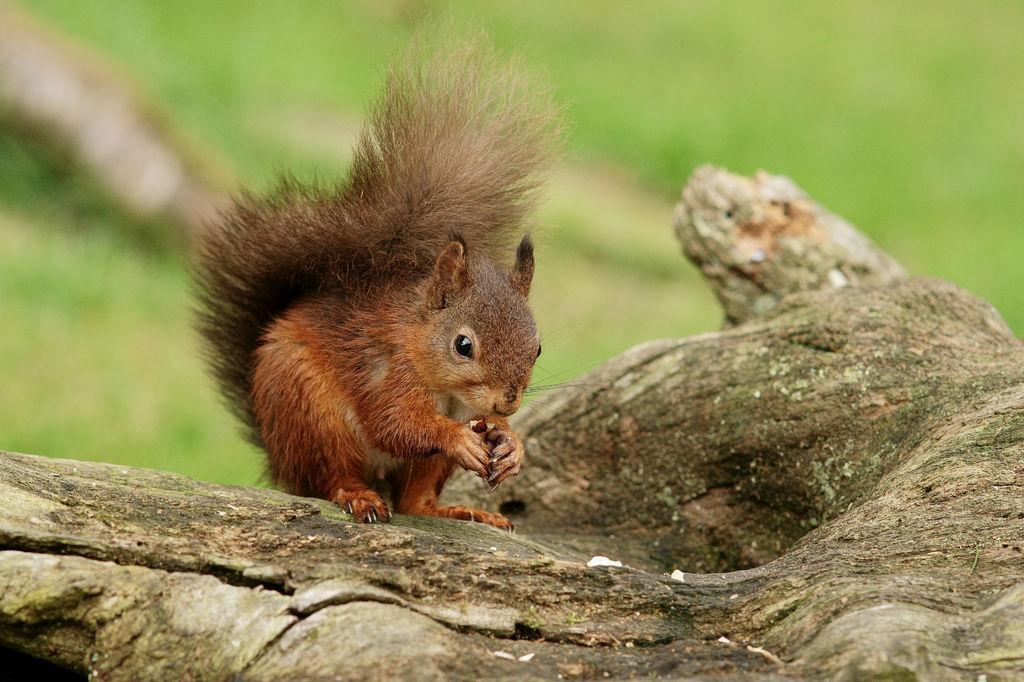Can you describe this image briefly? In this picture we can see fox squirrel on wood. He is holding some nut. On the background we can see green grass. 